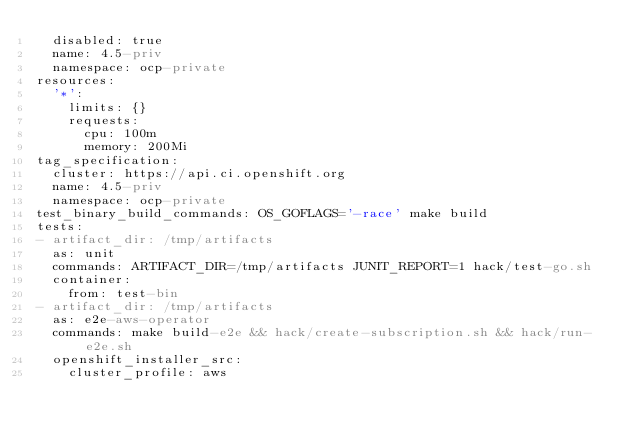Convert code to text. <code><loc_0><loc_0><loc_500><loc_500><_YAML_>  disabled: true
  name: 4.5-priv
  namespace: ocp-private
resources:
  '*':
    limits: {}
    requests:
      cpu: 100m
      memory: 200Mi
tag_specification:
  cluster: https://api.ci.openshift.org
  name: 4.5-priv
  namespace: ocp-private
test_binary_build_commands: OS_GOFLAGS='-race' make build
tests:
- artifact_dir: /tmp/artifacts
  as: unit
  commands: ARTIFACT_DIR=/tmp/artifacts JUNIT_REPORT=1 hack/test-go.sh
  container:
    from: test-bin
- artifact_dir: /tmp/artifacts
  as: e2e-aws-operator
  commands: make build-e2e && hack/create-subscription.sh && hack/run-e2e.sh
  openshift_installer_src:
    cluster_profile: aws
</code> 